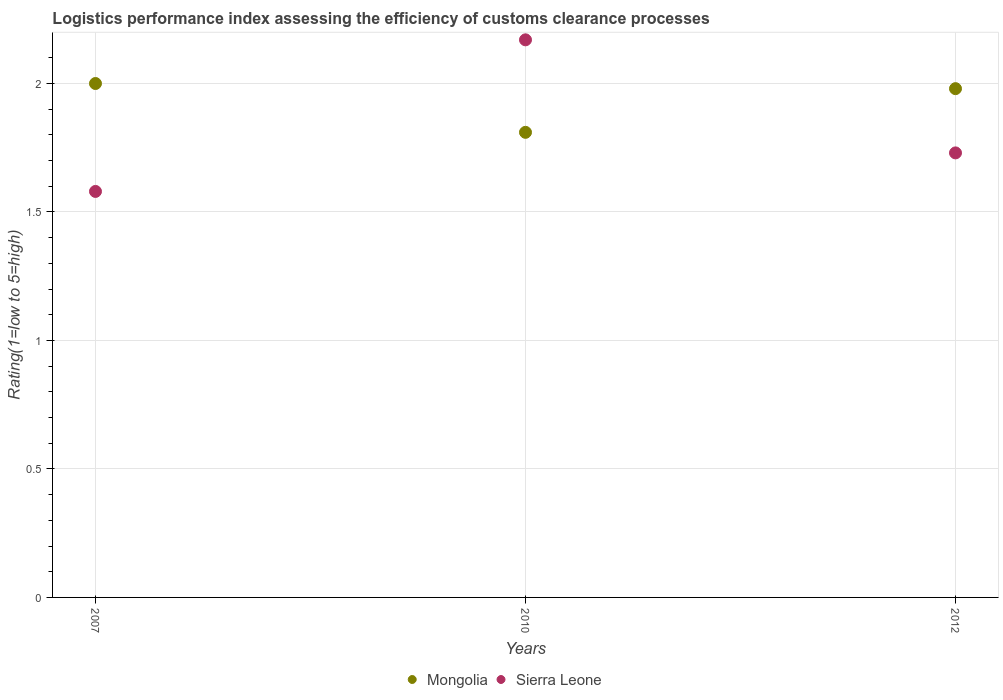How many different coloured dotlines are there?
Give a very brief answer. 2. Is the number of dotlines equal to the number of legend labels?
Make the answer very short. Yes. What is the Logistic performance index in Sierra Leone in 2010?
Keep it short and to the point. 2.17. Across all years, what is the maximum Logistic performance index in Mongolia?
Provide a short and direct response. 2. Across all years, what is the minimum Logistic performance index in Sierra Leone?
Give a very brief answer. 1.58. In which year was the Logistic performance index in Sierra Leone maximum?
Offer a terse response. 2010. In which year was the Logistic performance index in Mongolia minimum?
Provide a succinct answer. 2010. What is the total Logistic performance index in Sierra Leone in the graph?
Your answer should be compact. 5.48. What is the difference between the Logistic performance index in Mongolia in 2007 and that in 2010?
Keep it short and to the point. 0.19. What is the difference between the Logistic performance index in Sierra Leone in 2012 and the Logistic performance index in Mongolia in 2007?
Give a very brief answer. -0.27. What is the average Logistic performance index in Sierra Leone per year?
Provide a succinct answer. 1.83. In the year 2010, what is the difference between the Logistic performance index in Mongolia and Logistic performance index in Sierra Leone?
Ensure brevity in your answer.  -0.36. What is the ratio of the Logistic performance index in Sierra Leone in 2007 to that in 2010?
Ensure brevity in your answer.  0.73. Is the Logistic performance index in Mongolia in 2007 less than that in 2012?
Your answer should be very brief. No. What is the difference between the highest and the second highest Logistic performance index in Sierra Leone?
Provide a succinct answer. 0.44. What is the difference between the highest and the lowest Logistic performance index in Sierra Leone?
Your answer should be compact. 0.59. Does the Logistic performance index in Sierra Leone monotonically increase over the years?
Your answer should be compact. No. How many dotlines are there?
Ensure brevity in your answer.  2. What is the difference between two consecutive major ticks on the Y-axis?
Your response must be concise. 0.5. Are the values on the major ticks of Y-axis written in scientific E-notation?
Make the answer very short. No. Does the graph contain any zero values?
Keep it short and to the point. No. Does the graph contain grids?
Offer a terse response. Yes. How are the legend labels stacked?
Offer a terse response. Horizontal. What is the title of the graph?
Provide a short and direct response. Logistics performance index assessing the efficiency of customs clearance processes. Does "Haiti" appear as one of the legend labels in the graph?
Your answer should be compact. No. What is the label or title of the X-axis?
Offer a very short reply. Years. What is the label or title of the Y-axis?
Provide a succinct answer. Rating(1=low to 5=high). What is the Rating(1=low to 5=high) of Mongolia in 2007?
Your response must be concise. 2. What is the Rating(1=low to 5=high) of Sierra Leone in 2007?
Your answer should be very brief. 1.58. What is the Rating(1=low to 5=high) in Mongolia in 2010?
Offer a terse response. 1.81. What is the Rating(1=low to 5=high) of Sierra Leone in 2010?
Your response must be concise. 2.17. What is the Rating(1=low to 5=high) in Mongolia in 2012?
Your answer should be very brief. 1.98. What is the Rating(1=low to 5=high) of Sierra Leone in 2012?
Offer a very short reply. 1.73. Across all years, what is the maximum Rating(1=low to 5=high) in Sierra Leone?
Ensure brevity in your answer.  2.17. Across all years, what is the minimum Rating(1=low to 5=high) of Mongolia?
Keep it short and to the point. 1.81. Across all years, what is the minimum Rating(1=low to 5=high) of Sierra Leone?
Your response must be concise. 1.58. What is the total Rating(1=low to 5=high) in Mongolia in the graph?
Offer a terse response. 5.79. What is the total Rating(1=low to 5=high) of Sierra Leone in the graph?
Keep it short and to the point. 5.48. What is the difference between the Rating(1=low to 5=high) in Mongolia in 2007 and that in 2010?
Your response must be concise. 0.19. What is the difference between the Rating(1=low to 5=high) in Sierra Leone in 2007 and that in 2010?
Your answer should be very brief. -0.59. What is the difference between the Rating(1=low to 5=high) of Mongolia in 2007 and that in 2012?
Keep it short and to the point. 0.02. What is the difference between the Rating(1=low to 5=high) in Sierra Leone in 2007 and that in 2012?
Offer a very short reply. -0.15. What is the difference between the Rating(1=low to 5=high) in Mongolia in 2010 and that in 2012?
Provide a succinct answer. -0.17. What is the difference between the Rating(1=low to 5=high) in Sierra Leone in 2010 and that in 2012?
Provide a short and direct response. 0.44. What is the difference between the Rating(1=low to 5=high) in Mongolia in 2007 and the Rating(1=low to 5=high) in Sierra Leone in 2010?
Provide a succinct answer. -0.17. What is the difference between the Rating(1=low to 5=high) of Mongolia in 2007 and the Rating(1=low to 5=high) of Sierra Leone in 2012?
Give a very brief answer. 0.27. What is the average Rating(1=low to 5=high) in Mongolia per year?
Keep it short and to the point. 1.93. What is the average Rating(1=low to 5=high) of Sierra Leone per year?
Your response must be concise. 1.83. In the year 2007, what is the difference between the Rating(1=low to 5=high) in Mongolia and Rating(1=low to 5=high) in Sierra Leone?
Give a very brief answer. 0.42. In the year 2010, what is the difference between the Rating(1=low to 5=high) of Mongolia and Rating(1=low to 5=high) of Sierra Leone?
Make the answer very short. -0.36. In the year 2012, what is the difference between the Rating(1=low to 5=high) in Mongolia and Rating(1=low to 5=high) in Sierra Leone?
Keep it short and to the point. 0.25. What is the ratio of the Rating(1=low to 5=high) of Mongolia in 2007 to that in 2010?
Offer a terse response. 1.1. What is the ratio of the Rating(1=low to 5=high) of Sierra Leone in 2007 to that in 2010?
Your response must be concise. 0.73. What is the ratio of the Rating(1=low to 5=high) in Sierra Leone in 2007 to that in 2012?
Your response must be concise. 0.91. What is the ratio of the Rating(1=low to 5=high) of Mongolia in 2010 to that in 2012?
Provide a succinct answer. 0.91. What is the ratio of the Rating(1=low to 5=high) in Sierra Leone in 2010 to that in 2012?
Offer a terse response. 1.25. What is the difference between the highest and the second highest Rating(1=low to 5=high) of Sierra Leone?
Give a very brief answer. 0.44. What is the difference between the highest and the lowest Rating(1=low to 5=high) in Mongolia?
Your answer should be very brief. 0.19. What is the difference between the highest and the lowest Rating(1=low to 5=high) in Sierra Leone?
Your answer should be compact. 0.59. 